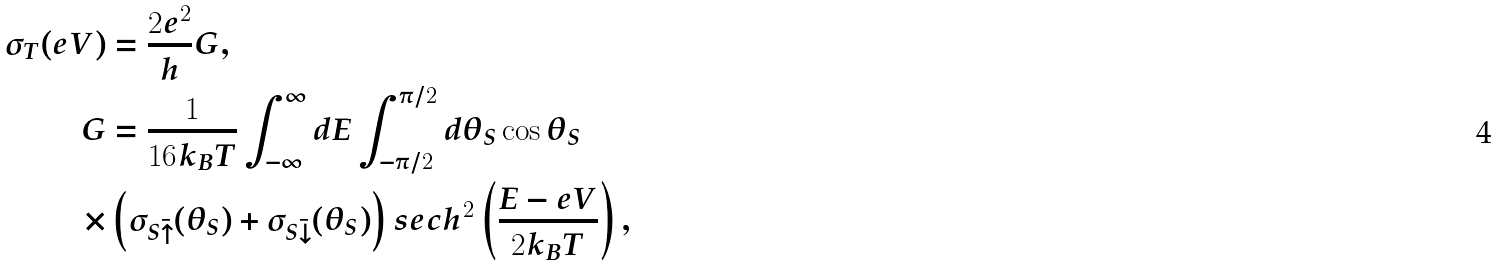<formula> <loc_0><loc_0><loc_500><loc_500>\sigma _ { T } ( e V ) & = \frac { 2 e ^ { 2 } } { h } G , \\ G & = \frac { 1 } { 1 6 k _ { B } T } \int _ { - \infty } ^ { \infty } d E \int _ { - \pi / 2 } ^ { \pi / 2 } d \theta _ { S } \cos { \theta _ { S } } \\ \times & \left ( \sigma _ { S \bar { \uparrow } } ( \theta _ { S } ) + \sigma _ { S \bar { \downarrow } } ( \theta _ { S } ) \right ) s e c h ^ { 2 } \left ( \frac { E - e V } { 2 k _ { B } T } \right ) ,</formula> 